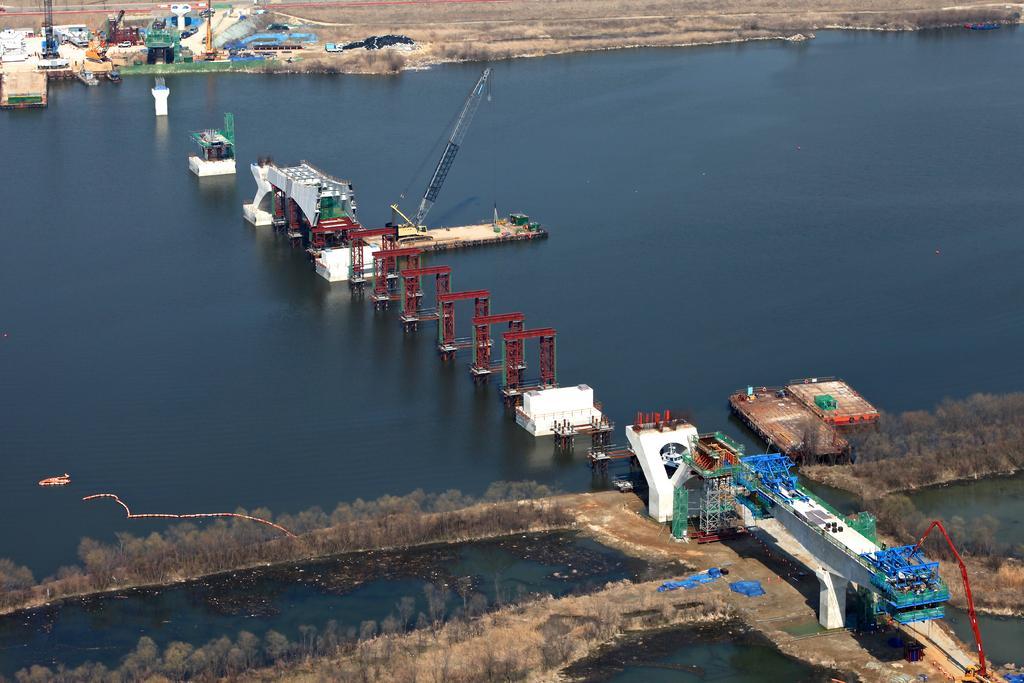Can you describe this image briefly? In this image, we can see some trees. There are some pillars in the water. There is a crane in the middle of the image. There are some objects in the top left of the image. 